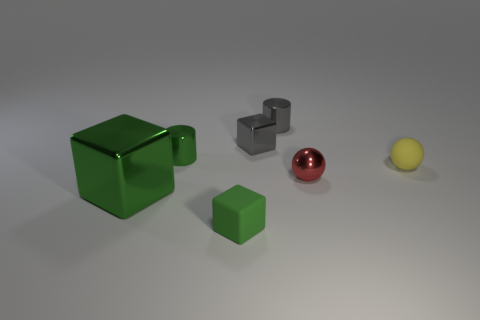Subtract all small blocks. How many blocks are left? 1 Subtract all gray blocks. How many blocks are left? 2 Subtract all spheres. How many objects are left? 5 Subtract 2 cylinders. How many cylinders are left? 0 Add 1 green metallic cylinders. How many objects exist? 8 Subtract all cyan blocks. Subtract all purple spheres. How many blocks are left? 3 Subtract all red cubes. How many yellow balls are left? 1 Subtract all tiny green rubber cubes. Subtract all small red metal spheres. How many objects are left? 5 Add 1 tiny objects. How many tiny objects are left? 7 Add 4 big yellow matte cubes. How many big yellow matte cubes exist? 4 